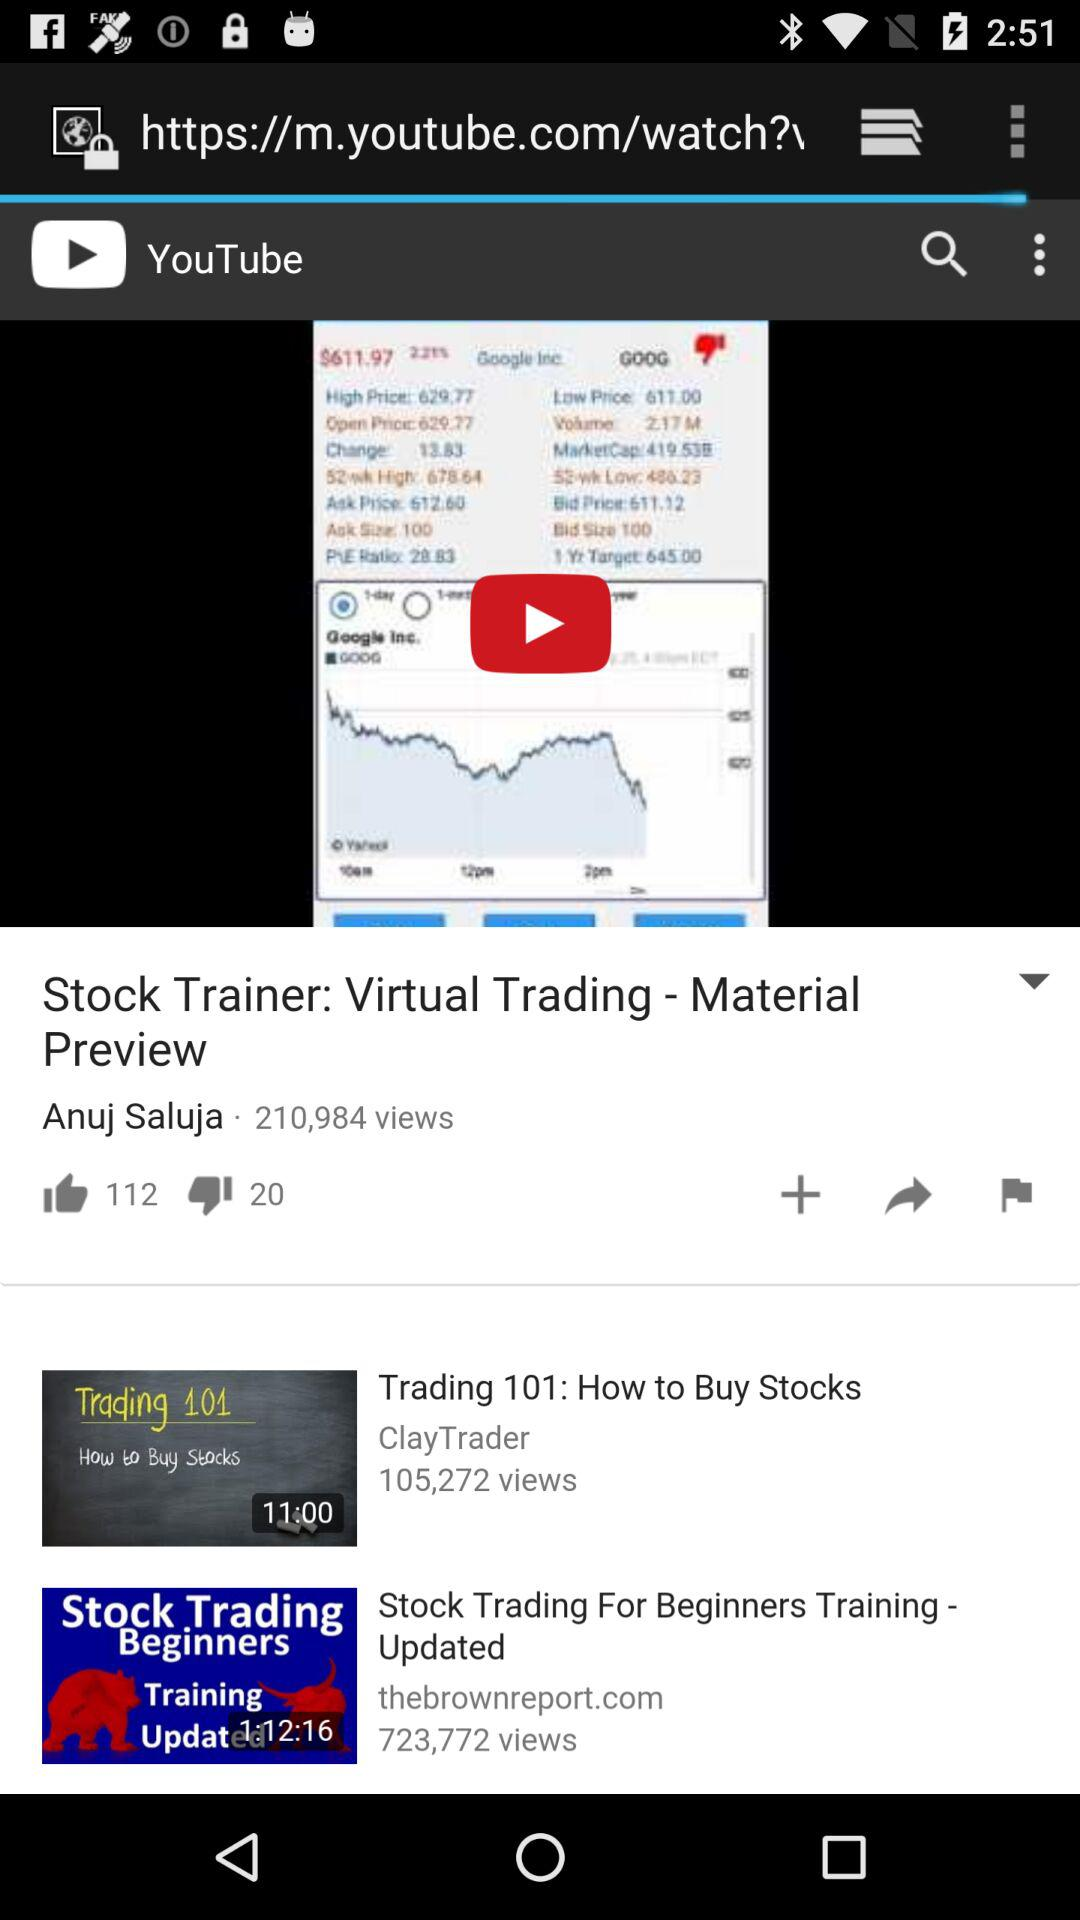How many views on "Trading 101: How to Buy Stocks" video? There are 105,272 views. 